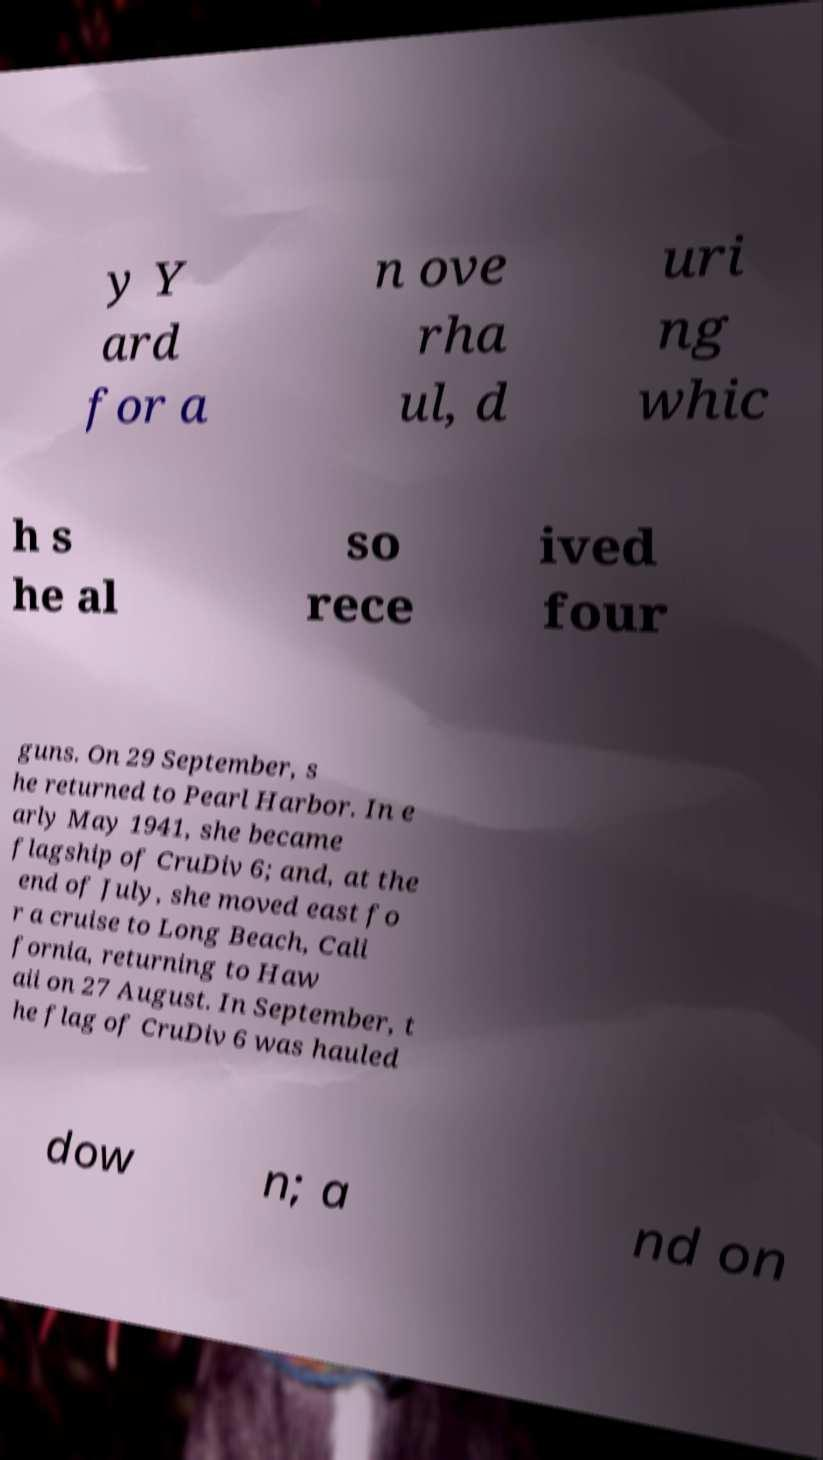For documentation purposes, I need the text within this image transcribed. Could you provide that? y Y ard for a n ove rha ul, d uri ng whic h s he al so rece ived four guns. On 29 September, s he returned to Pearl Harbor. In e arly May 1941, she became flagship of CruDiv 6; and, at the end of July, she moved east fo r a cruise to Long Beach, Cali fornia, returning to Haw aii on 27 August. In September, t he flag of CruDiv 6 was hauled dow n; a nd on 